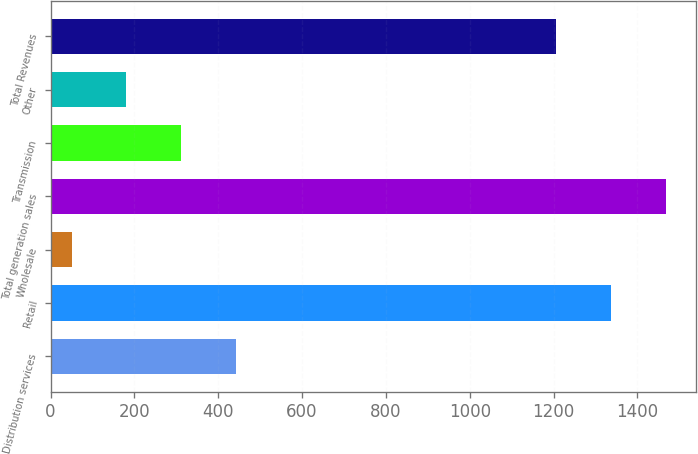<chart> <loc_0><loc_0><loc_500><loc_500><bar_chart><fcel>Distribution services<fcel>Retail<fcel>Wholesale<fcel>Total generation sales<fcel>Transmission<fcel>Other<fcel>Total Revenues<nl><fcel>442.1<fcel>1336.7<fcel>50<fcel>1467.4<fcel>311.4<fcel>180.7<fcel>1206<nl></chart> 